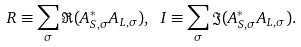Convert formula to latex. <formula><loc_0><loc_0><loc_500><loc_500>R \equiv \sum _ { \sigma } \Re ( A _ { S , \sigma } ^ { \ast } A _ { L , \sigma } ) , \ I \equiv \sum _ { \sigma } \Im ( A _ { S , \sigma } ^ { \ast } A _ { L , \sigma } ) .</formula> 